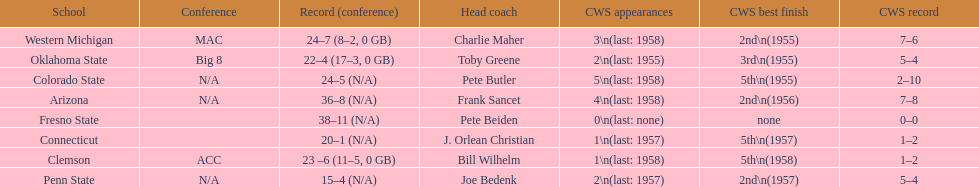What are the number of schools with more than 2 cws appearances? 3. 